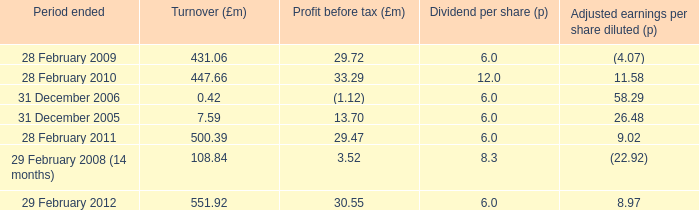What was the turnover when the profit before tax was 29.47? 500.39. 